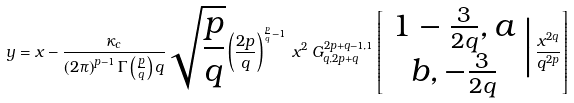Convert formula to latex. <formula><loc_0><loc_0><loc_500><loc_500>y = x - \frac { \kappa _ { c } } { \left ( 2 \pi \right ) ^ { p - 1 } \Gamma \left ( \frac { p } { q } \right ) q } \sqrt { \frac { p } { q } } \left ( \frac { 2 p } { q } \right ) ^ { \frac { p } { q } - 1 } \, x ^ { 2 } \, G _ { q , 2 p + q } ^ { 2 p + q - 1 , 1 } \left [ \begin{array} { c } 1 - \frac { 3 } { 2 q } , a \\ b , - \frac { 3 } { 2 q } \end{array} \Big | \, \frac { x ^ { 2 q } } { q ^ { 2 p } } \right ]</formula> 